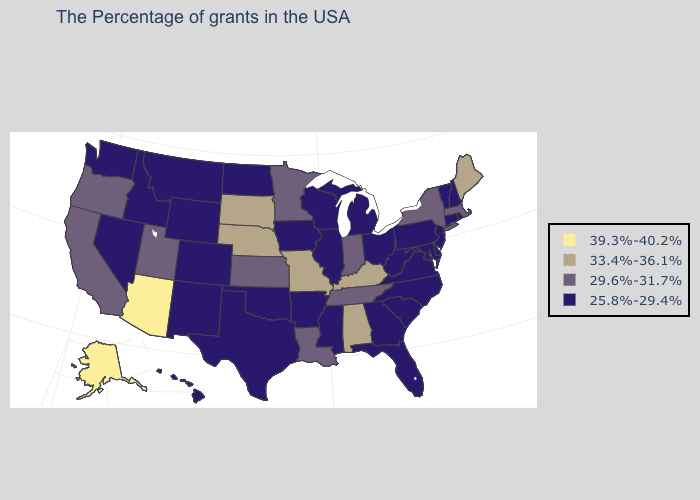Name the states that have a value in the range 25.8%-29.4%?
Be succinct. Rhode Island, New Hampshire, Vermont, Connecticut, New Jersey, Delaware, Maryland, Pennsylvania, Virginia, North Carolina, South Carolina, West Virginia, Ohio, Florida, Georgia, Michigan, Wisconsin, Illinois, Mississippi, Arkansas, Iowa, Oklahoma, Texas, North Dakota, Wyoming, Colorado, New Mexico, Montana, Idaho, Nevada, Washington, Hawaii. Name the states that have a value in the range 25.8%-29.4%?
Concise answer only. Rhode Island, New Hampshire, Vermont, Connecticut, New Jersey, Delaware, Maryland, Pennsylvania, Virginia, North Carolina, South Carolina, West Virginia, Ohio, Florida, Georgia, Michigan, Wisconsin, Illinois, Mississippi, Arkansas, Iowa, Oklahoma, Texas, North Dakota, Wyoming, Colorado, New Mexico, Montana, Idaho, Nevada, Washington, Hawaii. What is the value of California?
Give a very brief answer. 29.6%-31.7%. Does Minnesota have the lowest value in the USA?
Concise answer only. No. Which states have the highest value in the USA?
Answer briefly. Arizona, Alaska. What is the lowest value in states that border Vermont?
Quick response, please. 25.8%-29.4%. Does Arizona have the highest value in the USA?
Write a very short answer. Yes. Which states have the highest value in the USA?
Quick response, please. Arizona, Alaska. Which states have the lowest value in the West?
Short answer required. Wyoming, Colorado, New Mexico, Montana, Idaho, Nevada, Washington, Hawaii. Name the states that have a value in the range 25.8%-29.4%?
Keep it brief. Rhode Island, New Hampshire, Vermont, Connecticut, New Jersey, Delaware, Maryland, Pennsylvania, Virginia, North Carolina, South Carolina, West Virginia, Ohio, Florida, Georgia, Michigan, Wisconsin, Illinois, Mississippi, Arkansas, Iowa, Oklahoma, Texas, North Dakota, Wyoming, Colorado, New Mexico, Montana, Idaho, Nevada, Washington, Hawaii. Which states have the lowest value in the MidWest?
Answer briefly. Ohio, Michigan, Wisconsin, Illinois, Iowa, North Dakota. How many symbols are there in the legend?
Be succinct. 4. Among the states that border Illinois , does Missouri have the lowest value?
Give a very brief answer. No. How many symbols are there in the legend?
Keep it brief. 4. What is the lowest value in the USA?
Keep it brief. 25.8%-29.4%. 